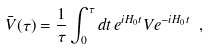<formula> <loc_0><loc_0><loc_500><loc_500>\bar { V } ( \tau ) = \frac { 1 } { \tau } \int _ { 0 } ^ { \tau } d t \, e ^ { i H _ { 0 } t } V e ^ { - i H _ { 0 } t } \ ,</formula> 